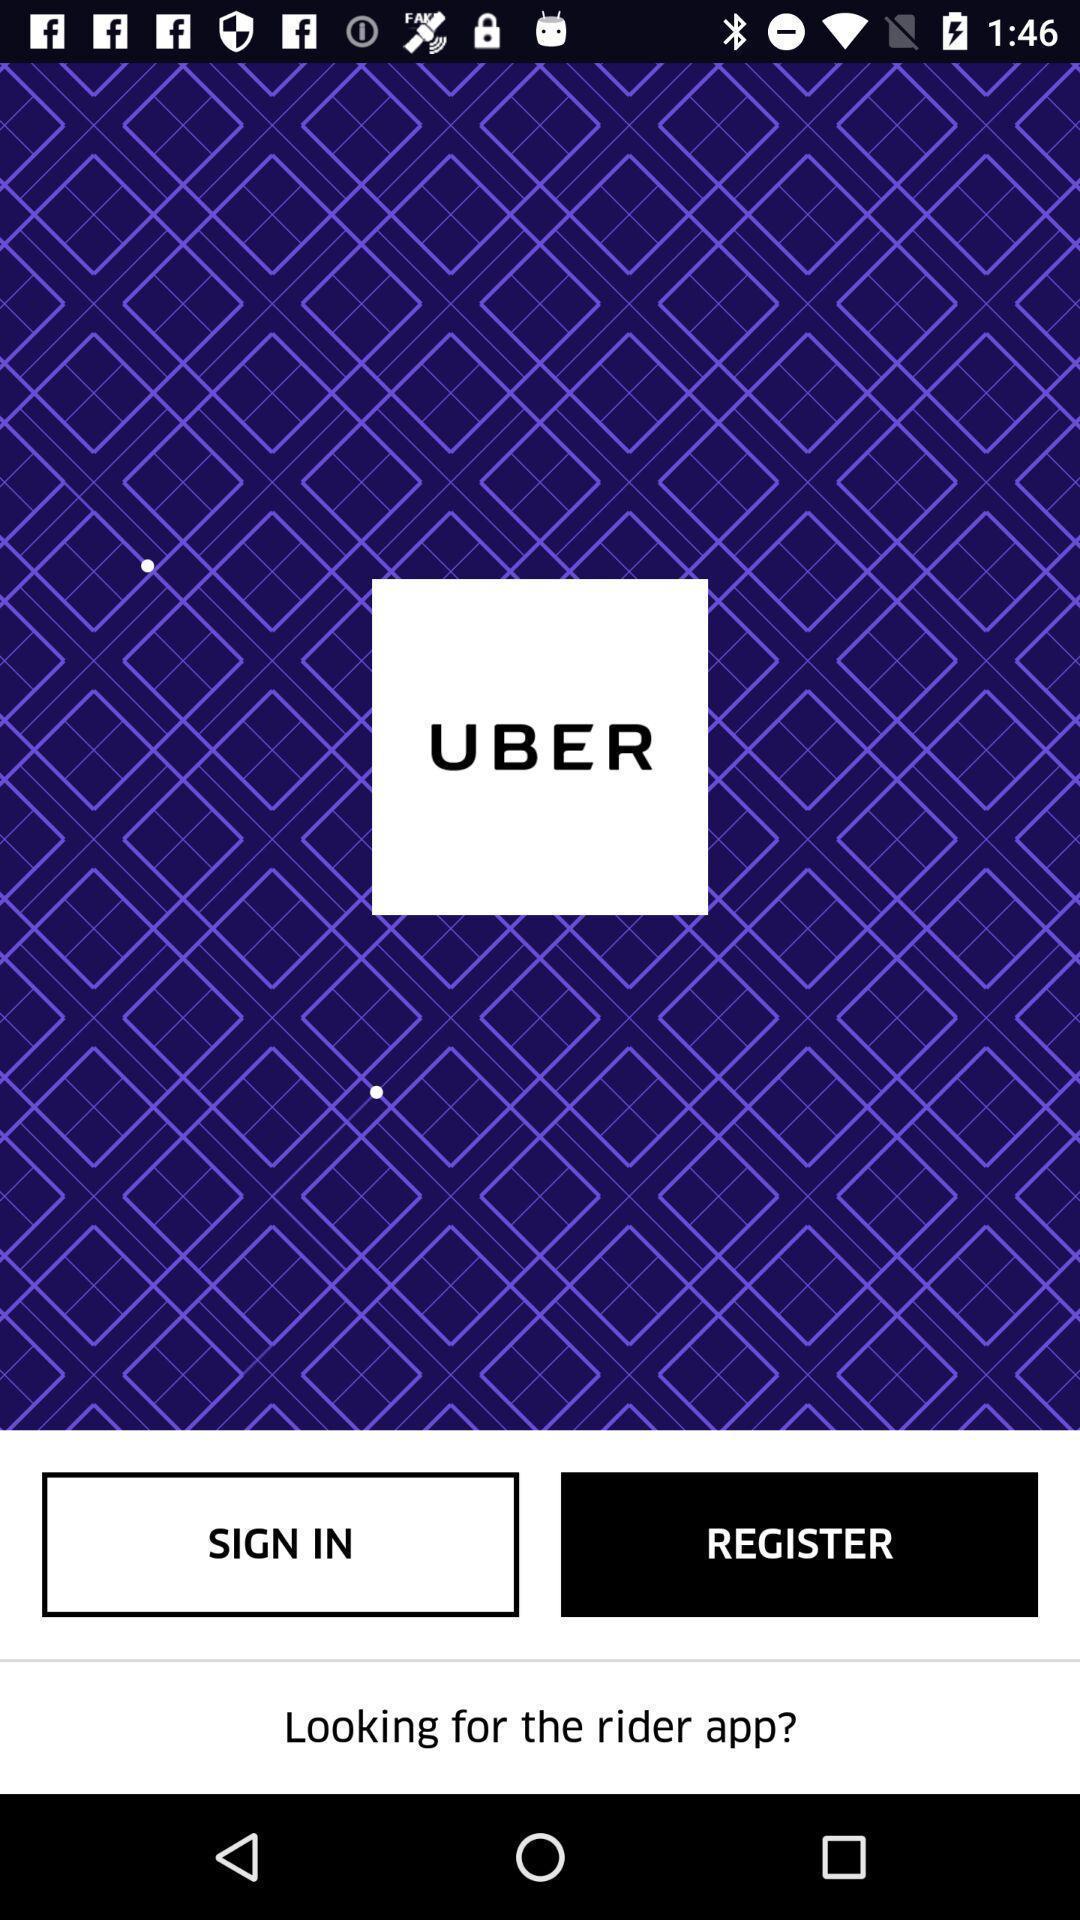Please provide a description for this image. Signup page s. 